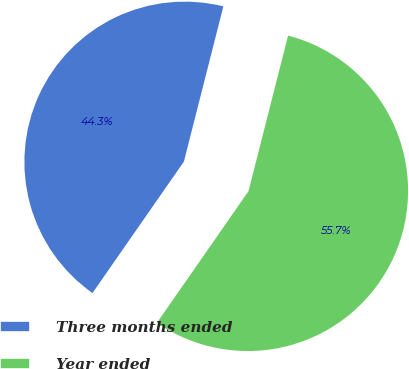Convert chart to OTSL. <chart><loc_0><loc_0><loc_500><loc_500><pie_chart><fcel>Three months ended<fcel>Year ended<nl><fcel>44.29%<fcel>55.71%<nl></chart> 